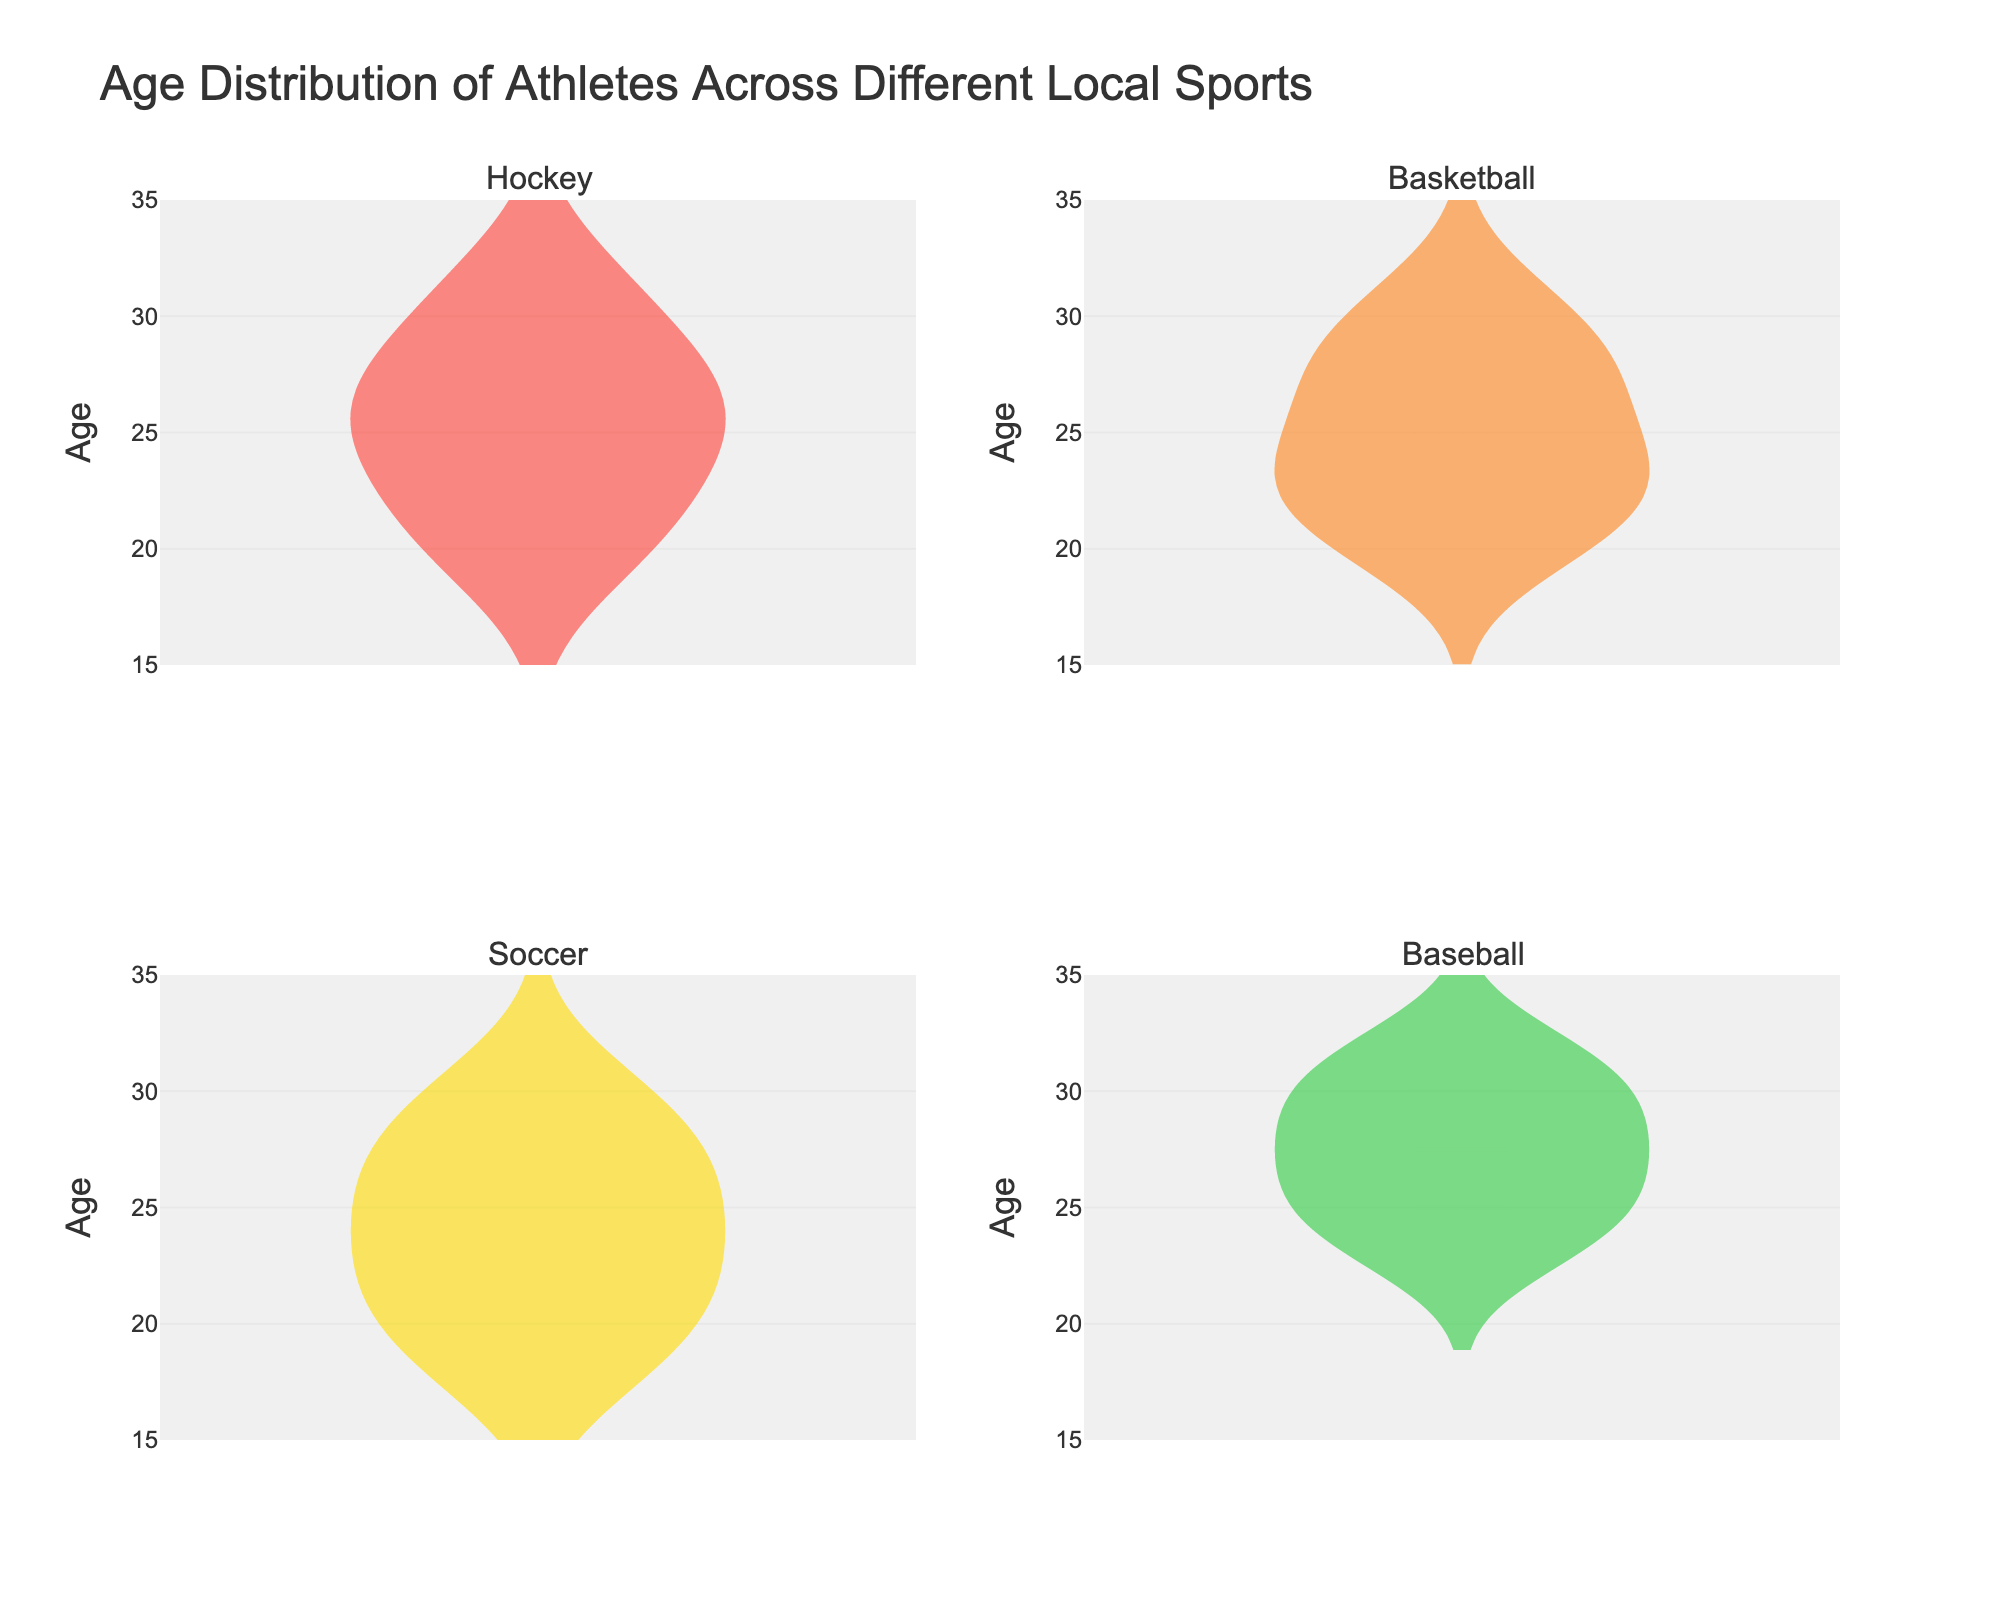What's the title of the figure? It's written at the top of the figure. The title reads "Age Distribution of Athletes Across Different Local Sports".
Answer: Age Distribution of Athletes Across Different Local Sports What is the age range shown on the y-axes? The y-axis on all subplots shows ages ranging from 15 to 35. This range is displayed on each subplot's y-axis.
Answer: 15 to 35 Which sport has athletes with the widest age distribution? By looking at the width of the violin plots, Hockey has a wider age distribution because it spans more ages compared to the other sports.
Answer: Hockey What's the color used for the violin plot of Soccer? Each violin plot has a distinct color. The color used for Soccer is yellow.
Answer: Yellow Which sport has the highest median age of athletes? The median is shown by a line within each violin plot. Baseball has the highest median because its median line is positioned higher on the y-axis than the other sports.
Answer: Baseball What is the median age for Basketball players? The Basketball subplot's median line is around 24 on the y-axis, indicating the median age.
Answer: 24 How does the mean age of Soccer players compare to that of Hockey players? The mean is displayed as a line within each violin plot. The mean age for Soccer is higher than for Hockey when comparing the positions of their respective lines.
Answer: Soccer is higher Which sport has the smallest interquartile range (IQR) of ages? The IQR is reflected by the spread between the 25th and 75th percentiles within the violin plot. Basketball has the smallest IQR as it appears less spread out compared to the others.
Answer: Basketball What is the approximate mean age of Baseball players? The mean line on the Baseball subplot is positioned around age 27 on the y-axis.
Answer: 27 Which sport has the oldest athlete? By looking at the highest point on the y-axis for each violin plot, the oldest athlete appears in Baseball, around age 32.
Answer: Baseball 